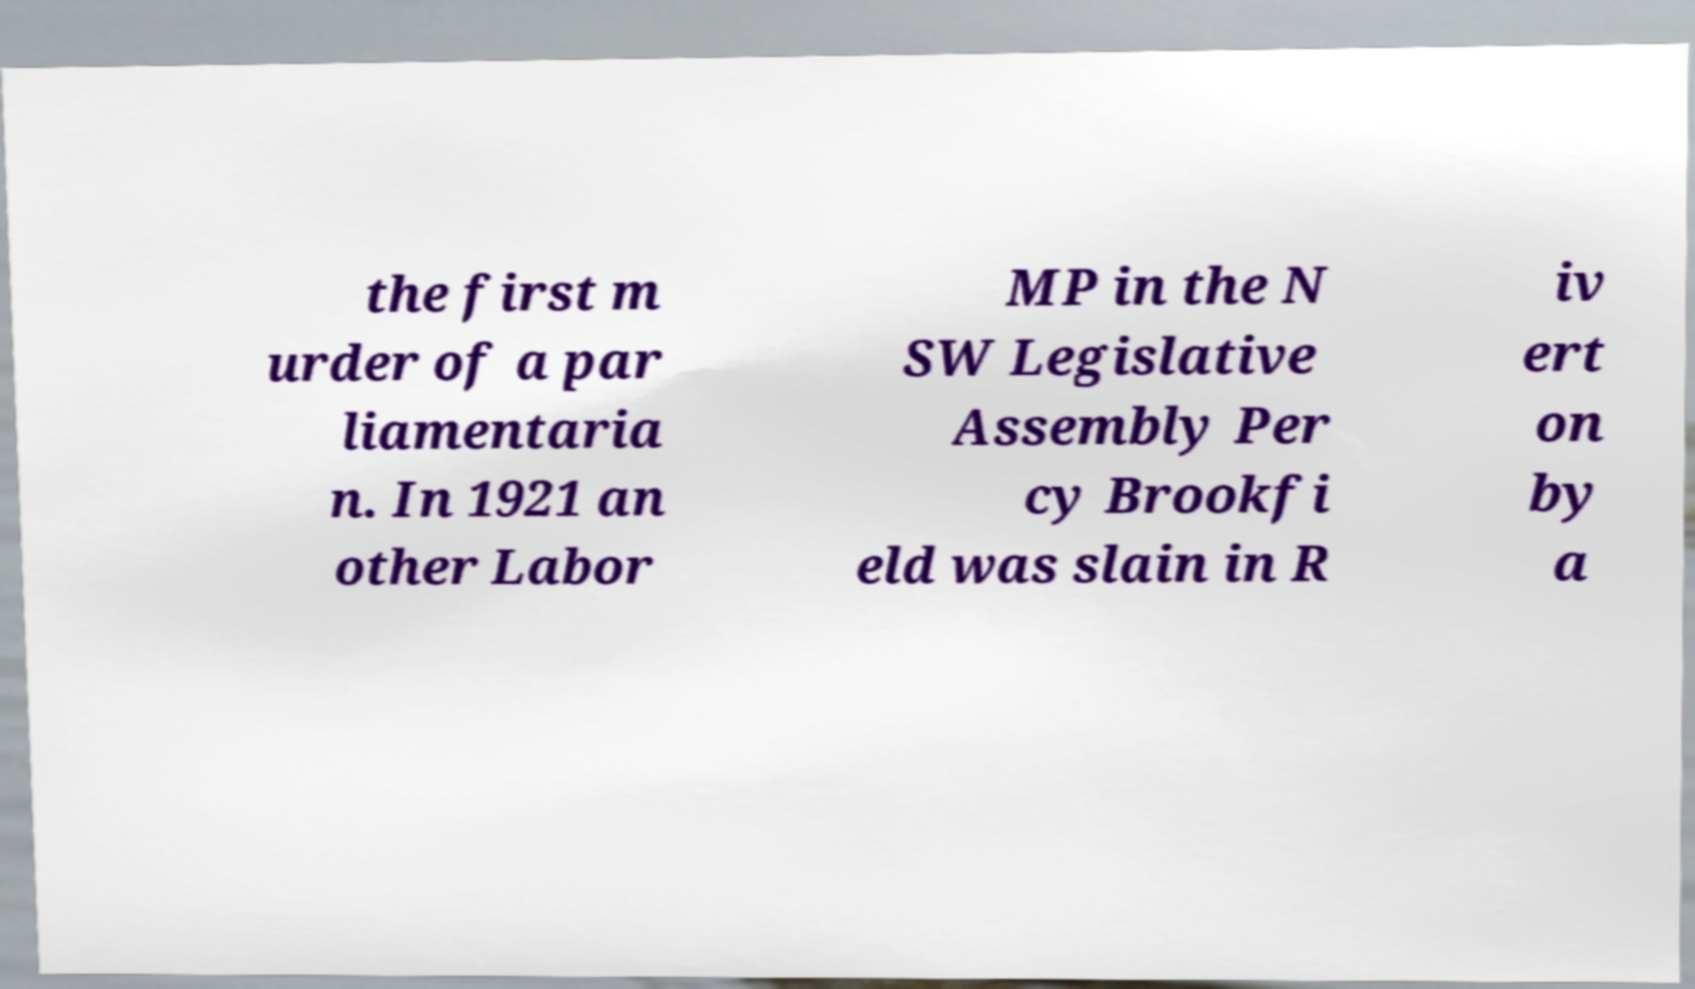For documentation purposes, I need the text within this image transcribed. Could you provide that? the first m urder of a par liamentaria n. In 1921 an other Labor MP in the N SW Legislative Assembly Per cy Brookfi eld was slain in R iv ert on by a 